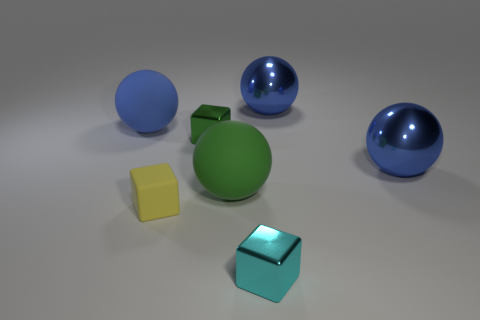Subtract all blue spheres. How many were subtracted if there are1blue spheres left? 2 Subtract all green blocks. How many blue balls are left? 3 Add 1 cyan blocks. How many objects exist? 8 Subtract all balls. How many objects are left? 3 Subtract 0 purple balls. How many objects are left? 7 Subtract all cyan metal blocks. Subtract all green things. How many objects are left? 4 Add 5 large green matte objects. How many large green matte objects are left? 6 Add 6 blocks. How many blocks exist? 9 